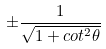<formula> <loc_0><loc_0><loc_500><loc_500>\pm \frac { 1 } { \sqrt { 1 + c o t ^ { 2 } \theta } }</formula> 